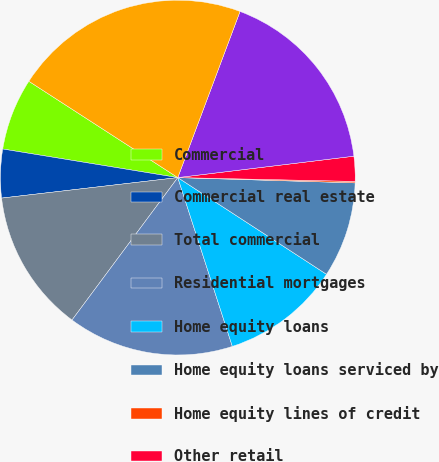<chart> <loc_0><loc_0><loc_500><loc_500><pie_chart><fcel>Commercial<fcel>Commercial real estate<fcel>Total commercial<fcel>Residential mortgages<fcel>Home equity loans<fcel>Home equity loans serviced by<fcel>Home equity lines of credit<fcel>Other retail<fcel>Total retail<fcel>Total<nl><fcel>6.56%<fcel>4.42%<fcel>12.99%<fcel>15.14%<fcel>10.85%<fcel>8.7%<fcel>0.13%<fcel>2.27%<fcel>17.37%<fcel>21.57%<nl></chart> 